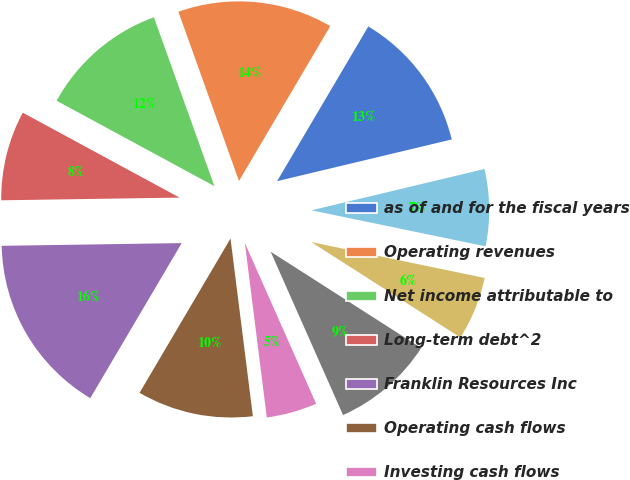Convert chart. <chart><loc_0><loc_0><loc_500><loc_500><pie_chart><fcel>as of and for the fiscal years<fcel>Operating revenues<fcel>Net income attributable to<fcel>Long-term debt^2<fcel>Franklin Resources Inc<fcel>Operating cash flows<fcel>Investing cash flows<fcel>Financing cash flows<fcel>Ending<fcel>Average^3<nl><fcel>12.79%<fcel>13.95%<fcel>11.63%<fcel>8.14%<fcel>16.28%<fcel>10.47%<fcel>4.65%<fcel>9.3%<fcel>5.81%<fcel>6.98%<nl></chart> 